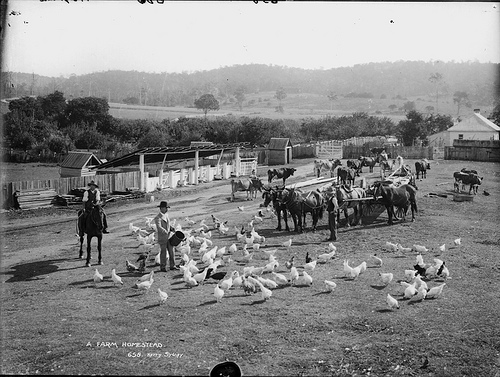<image>What type of event is taking place in the arena? I don't know what type of event is taking place in the arena. It could be farming, feeding or a petting zoo. What type of event is taking place in the arena? I don't know what type of event is taking place in the arena. It could be farm life, ploughing, feeding, flock, petting zoo, or farming. 